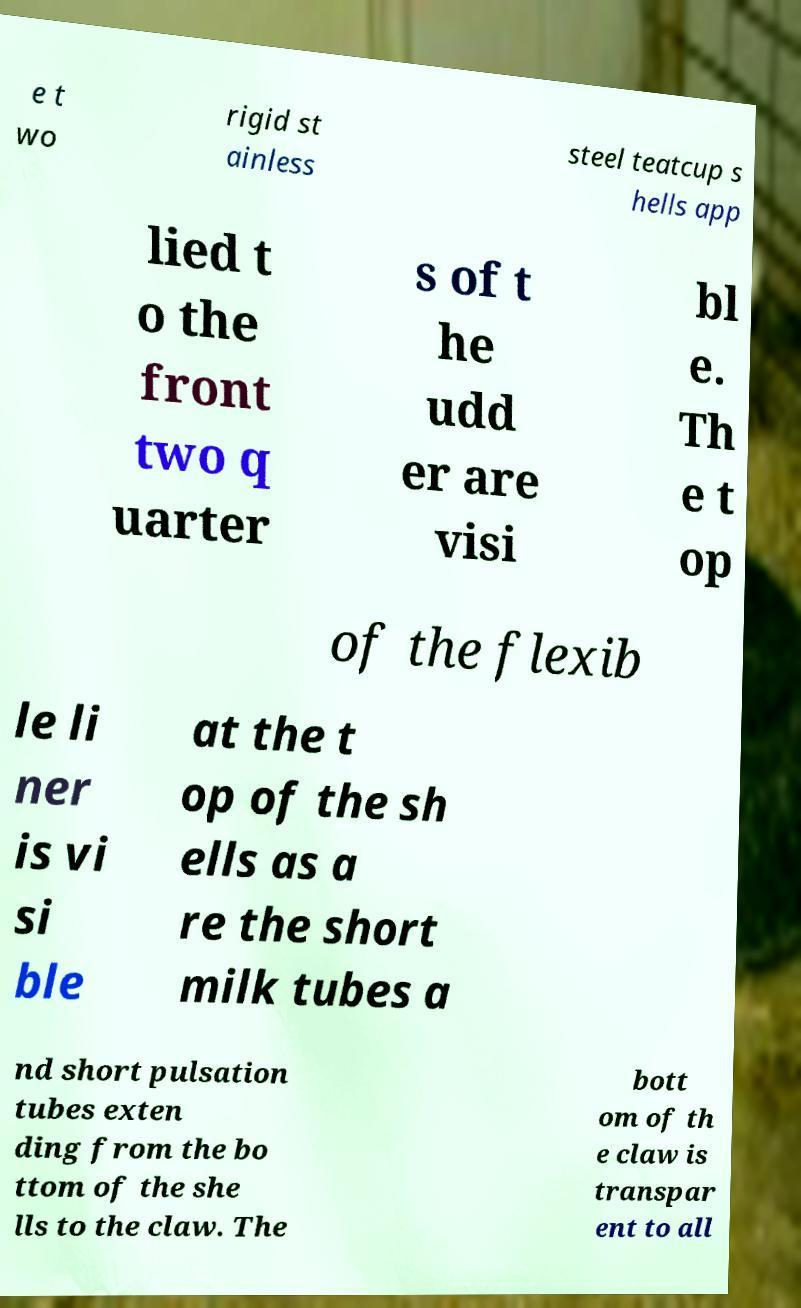There's text embedded in this image that I need extracted. Can you transcribe it verbatim? e t wo rigid st ainless steel teatcup s hells app lied t o the front two q uarter s of t he udd er are visi bl e. Th e t op of the flexib le li ner is vi si ble at the t op of the sh ells as a re the short milk tubes a nd short pulsation tubes exten ding from the bo ttom of the she lls to the claw. The bott om of th e claw is transpar ent to all 